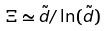Convert formula to latex. <formula><loc_0><loc_0><loc_500><loc_500>\Xi \simeq \tilde { d } / \ln ( \tilde { d } )</formula> 